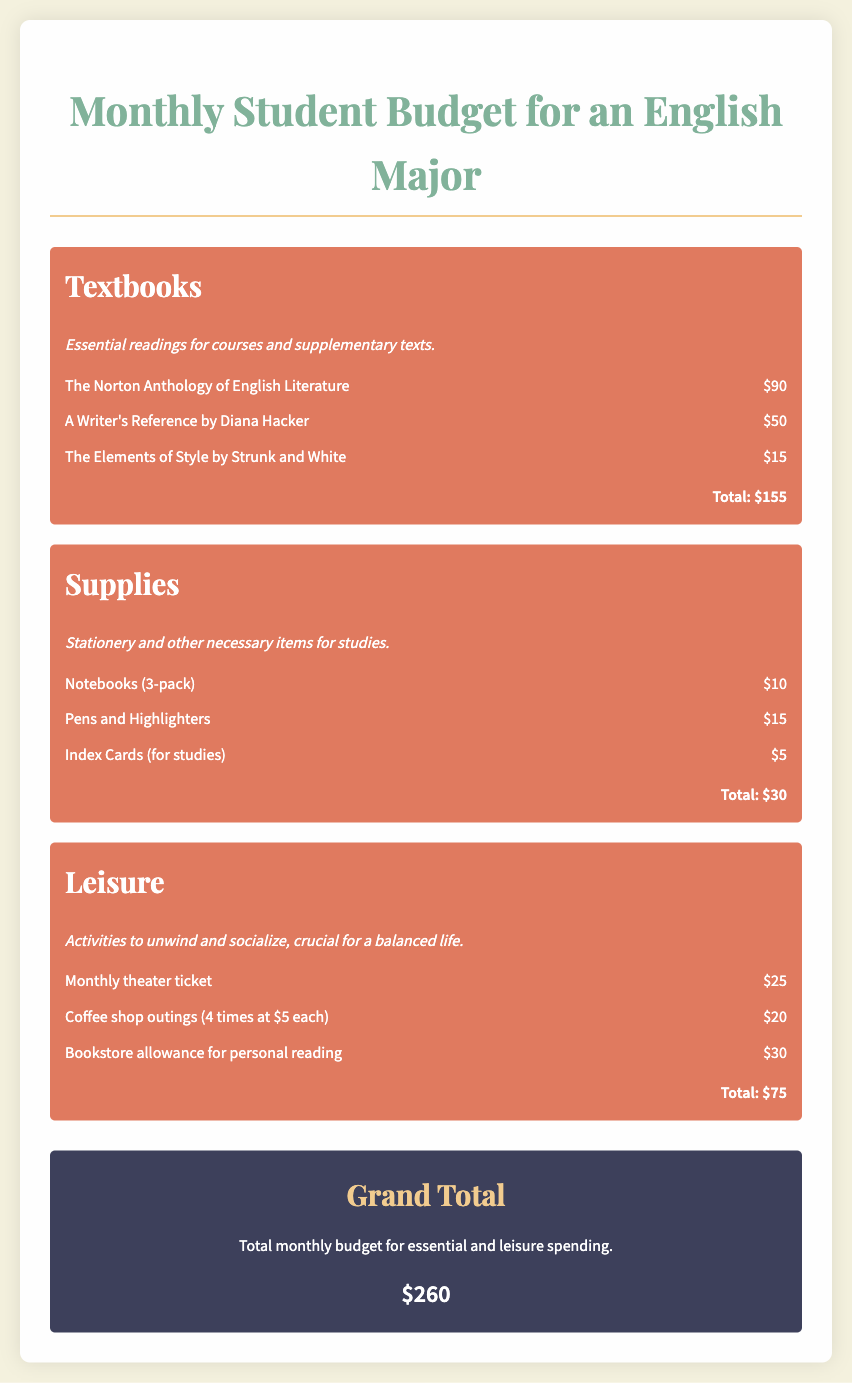What is the total amount spent on textbooks? The total amount spent on textbooks is detailed in the Textbooks section, which sums up to $155.
Answer: $155 What is included in the leisure expenses? The leisure expenses include activities such as a monthly theater ticket, coffee shop outings, and a bookstore allowance, as outlined in the Leisure section.
Answer: Monthly theater ticket, coffee shop outings, bookstore allowance How much is allocated for notebooks? The cost of notebooks is specified in the Supplies section, where a 3-pack is listed for $10.
Answer: $10 What is the grand total of the monthly budget? The grand total is the overall sum of all expenses combined, listed at the end of the document as $260.
Answer: $260 How many books are listed under textbooks? The Textbooks section lists three specific books, which are enumerated with their respective costs.
Answer: Three books What is the cost of A Writer's Reference? The specific cost of A Writer's Reference is mentioned directly in the Textbooks section as $50.
Answer: $50 What leisure activity has the highest expense? Among the leisure activities listed, the monthly theater ticket is noted to cost $25, which is the highest expense for leisure.
Answer: Monthly theater ticket What do the supplies expenses mainly consist of? The Supplies section primarily includes items like notebooks, pens, and index cards, as described in that category.
Answer: Notebooks, pens, index cards How much is budgeted for coffee shop outings? The budget allocated for coffee shop outings is detailed in the Leisure section as $20.
Answer: $20 